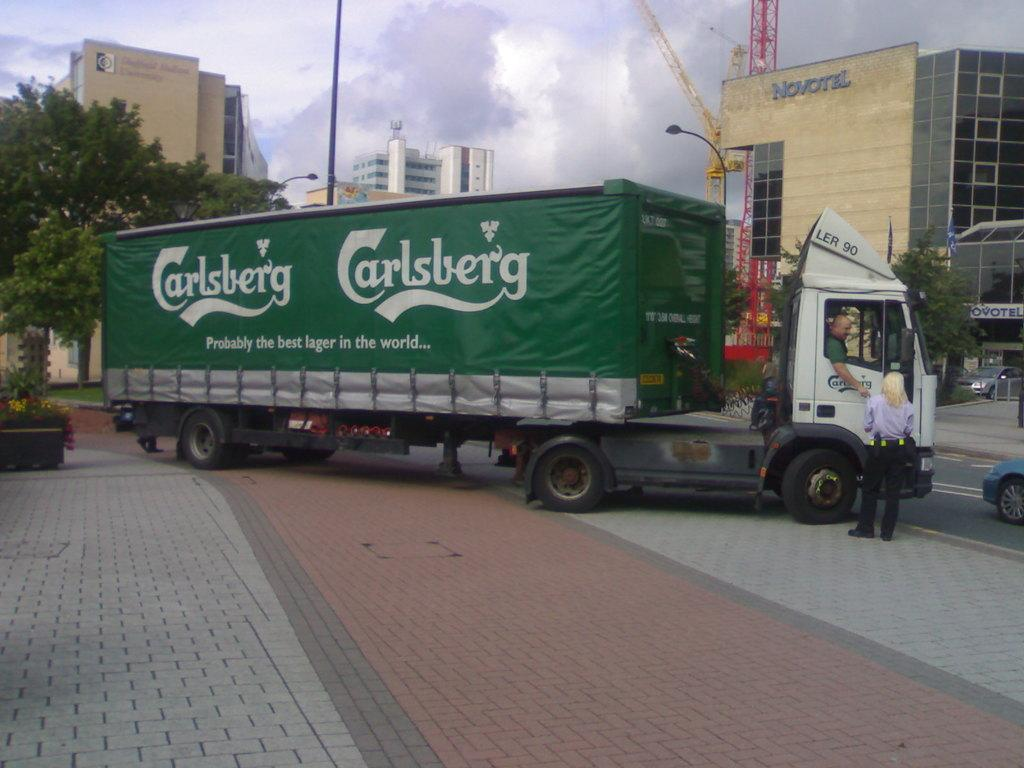What can be seen on the road in the image? There are vehicles on the road in the image. Who or what can be seen in the image besides the vehicles? There are people visible in the image. What is visible in the background of the image? There are buildings, trees, poles, and the sky visible in the background of the image. Can you tell me how many times the tramp jumps in the image? There is no tramp present in the image; it features vehicles on the road, people, and background elements such as buildings, trees, poles, and the sky. 